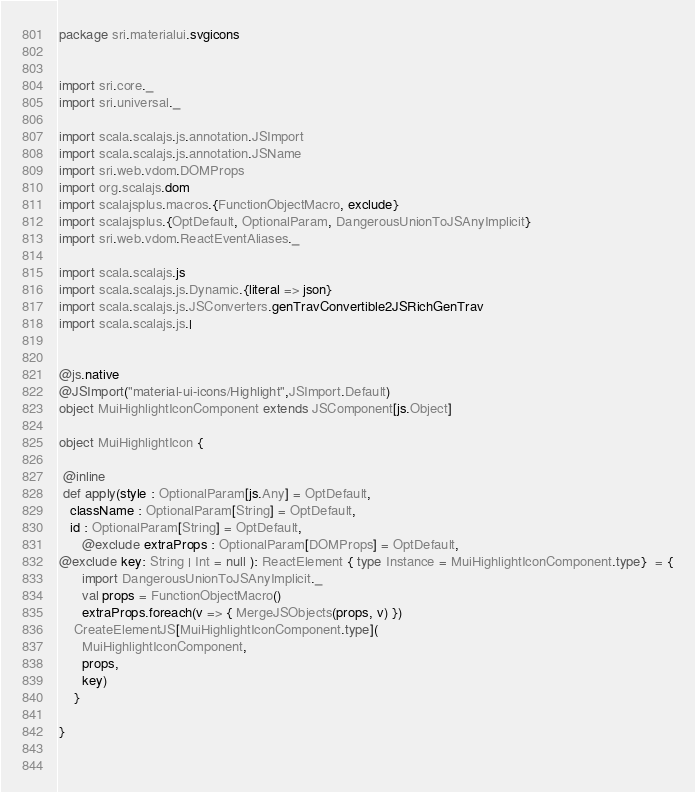Convert code to text. <code><loc_0><loc_0><loc_500><loc_500><_Scala_>package sri.materialui.svgicons


import sri.core._
import sri.universal._

import scala.scalajs.js.annotation.JSImport
import scala.scalajs.js.annotation.JSName
import sri.web.vdom.DOMProps
import org.scalajs.dom
import scalajsplus.macros.{FunctionObjectMacro, exclude}
import scalajsplus.{OptDefault, OptionalParam, DangerousUnionToJSAnyImplicit}
import sri.web.vdom.ReactEventAliases._

import scala.scalajs.js
import scala.scalajs.js.Dynamic.{literal => json}
import scala.scalajs.js.JSConverters.genTravConvertible2JSRichGenTrav
import scala.scalajs.js.|
     

@js.native
@JSImport("material-ui-icons/Highlight",JSImport.Default)
object MuiHighlightIconComponent extends JSComponent[js.Object]

object MuiHighlightIcon {

 @inline
 def apply(style : OptionalParam[js.Any] = OptDefault,
   className : OptionalParam[String] = OptDefault,
   id : OptionalParam[String] = OptDefault,
      @exclude extraProps : OptionalParam[DOMProps] = OptDefault,
@exclude key: String | Int = null ): ReactElement { type Instance = MuiHighlightIconComponent.type}  = {
      import DangerousUnionToJSAnyImplicit._
      val props = FunctionObjectMacro()
      extraProps.foreach(v => { MergeJSObjects(props, v) })
    CreateElementJS[MuiHighlightIconComponent.type](
      MuiHighlightIconComponent,
      props,
      key)
    }

}

        
</code> 